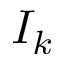Convert formula to latex. <formula><loc_0><loc_0><loc_500><loc_500>I _ { k }</formula> 